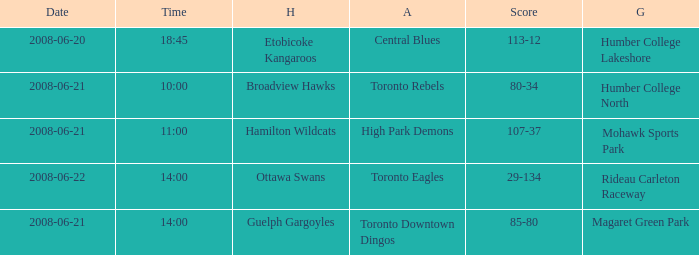What is the Date with a Home that is hamilton wildcats? 2008-06-21. 